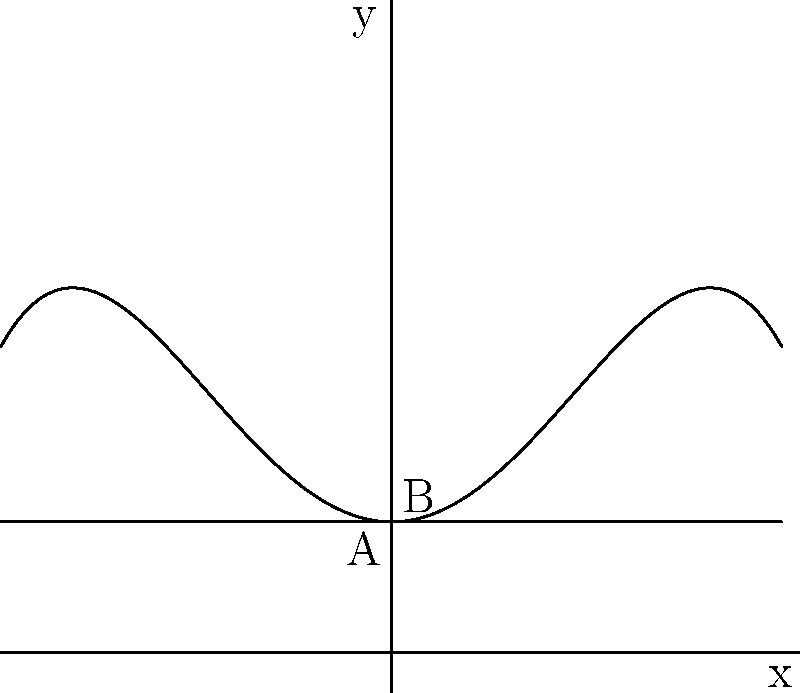A historical church bell's cross-section can be modeled by the polynomial function $f(x) = -0.05x^4 + 0.6x^2 + 1$, where $x$ is measured in feet. What is the height of the bell at its center, measured from the base (point A) to the highest point (point B)? To find the height of the bell at its center, we need to:

1. Determine the x-coordinate of the center: The bell is symmetrical, so the center is at $x = 0$.

2. Calculate the y-coordinate of point B by evaluating $f(0)$:
   $f(0) = -0.05(0)^4 + 0.6(0)^2 + 1$
   $f(0) = 0 + 0 + 1 = 1$

3. Find the y-coordinate of point A: The base of the bell is at $y = 1$.

4. Calculate the height by subtracting the y-coordinate of A from B:
   Height = $f(0) - 1 = 1 - 1 = 0$

Therefore, the height of the bell at its center is 0 feet.
Answer: 0 feet 